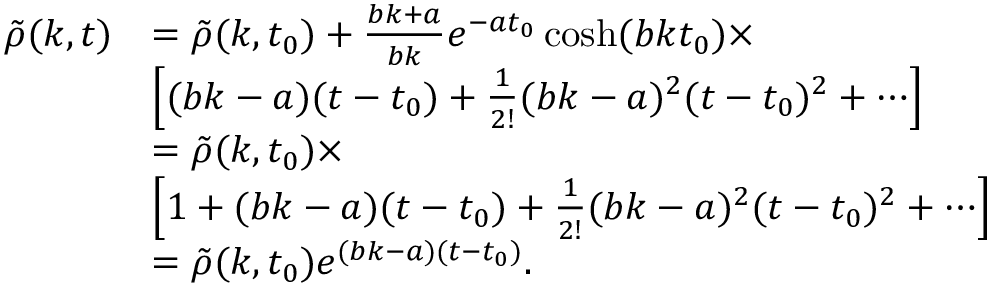<formula> <loc_0><loc_0><loc_500><loc_500>\begin{array} { r l } { \tilde { \rho } ( k , t ) } & { = \tilde { \rho } ( k , t _ { 0 } ) + \frac { b k + a } { b k } e ^ { - a t _ { 0 } } \cosh ( b k t _ { 0 } ) \times } \\ & { \left [ ( b k - a ) ( t - t _ { 0 } ) + \frac { 1 } { 2 ! } ( b k - a ) ^ { 2 } ( t - t _ { 0 } ) ^ { 2 } + \cdots \right ] } \\ & { = \tilde { \rho } ( k , t _ { 0 } ) \times } \\ & { \left [ 1 + ( b k - a ) ( t - t _ { 0 } ) + \frac { 1 } { 2 ! } ( b k - a ) ^ { 2 } ( t - t _ { 0 } ) ^ { 2 } + \cdots \right ] } \\ & { = \tilde { \rho } ( k , t _ { 0 } ) e ^ { ( b k - a ) ( t - t _ { 0 } ) } . } \end{array}</formula> 